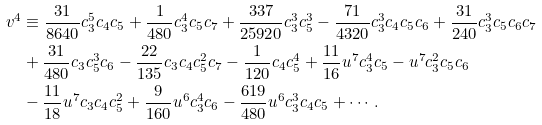<formula> <loc_0><loc_0><loc_500><loc_500>v ^ { 4 } & \equiv \frac { 3 1 } { 8 6 4 0 } c _ { 3 } ^ { 5 } c _ { 4 } c _ { 5 } + \frac { 1 } { 4 8 0 } c _ { 3 } ^ { 4 } c _ { 5 } c _ { 7 } + \frac { 3 3 7 } { 2 5 9 2 0 } c _ { 3 } ^ { 3 } c _ { 5 } ^ { 3 } - \frac { 7 1 } { 4 3 2 0 } c _ { 3 } ^ { 3 } c _ { 4 } c _ { 5 } c _ { 6 } + \frac { 3 1 } { 2 4 0 } c _ { 3 } ^ { 3 } c _ { 5 } c _ { 6 } c _ { 7 } \\ & + \frac { 3 1 } { 4 8 0 } c _ { 3 } c _ { 5 } ^ { 3 } c _ { 6 } - \frac { 2 2 } { 1 3 5 } c _ { 3 } c _ { 4 } c _ { 5 } ^ { 2 } c _ { 7 } - \frac { 1 } { 1 2 0 } c _ { 4 } c _ { 5 } ^ { 4 } + \frac { 1 1 } { 1 6 } u ^ { 7 } c _ { 3 } ^ { 4 } c _ { 5 } - u ^ { 7 } c _ { 3 } ^ { 2 } c _ { 5 } c _ { 6 } \\ & - \frac { 1 1 } { 1 8 } u ^ { 7 } c _ { 3 } c _ { 4 } c _ { 5 } ^ { 2 } + \frac { 9 } { 1 6 0 } u ^ { 6 } c _ { 3 } ^ { 4 } c _ { 6 } - \frac { 6 1 9 } { 4 8 0 } u ^ { 6 } c _ { 3 } ^ { 3 } c _ { 4 } c _ { 5 } + \cdots .</formula> 